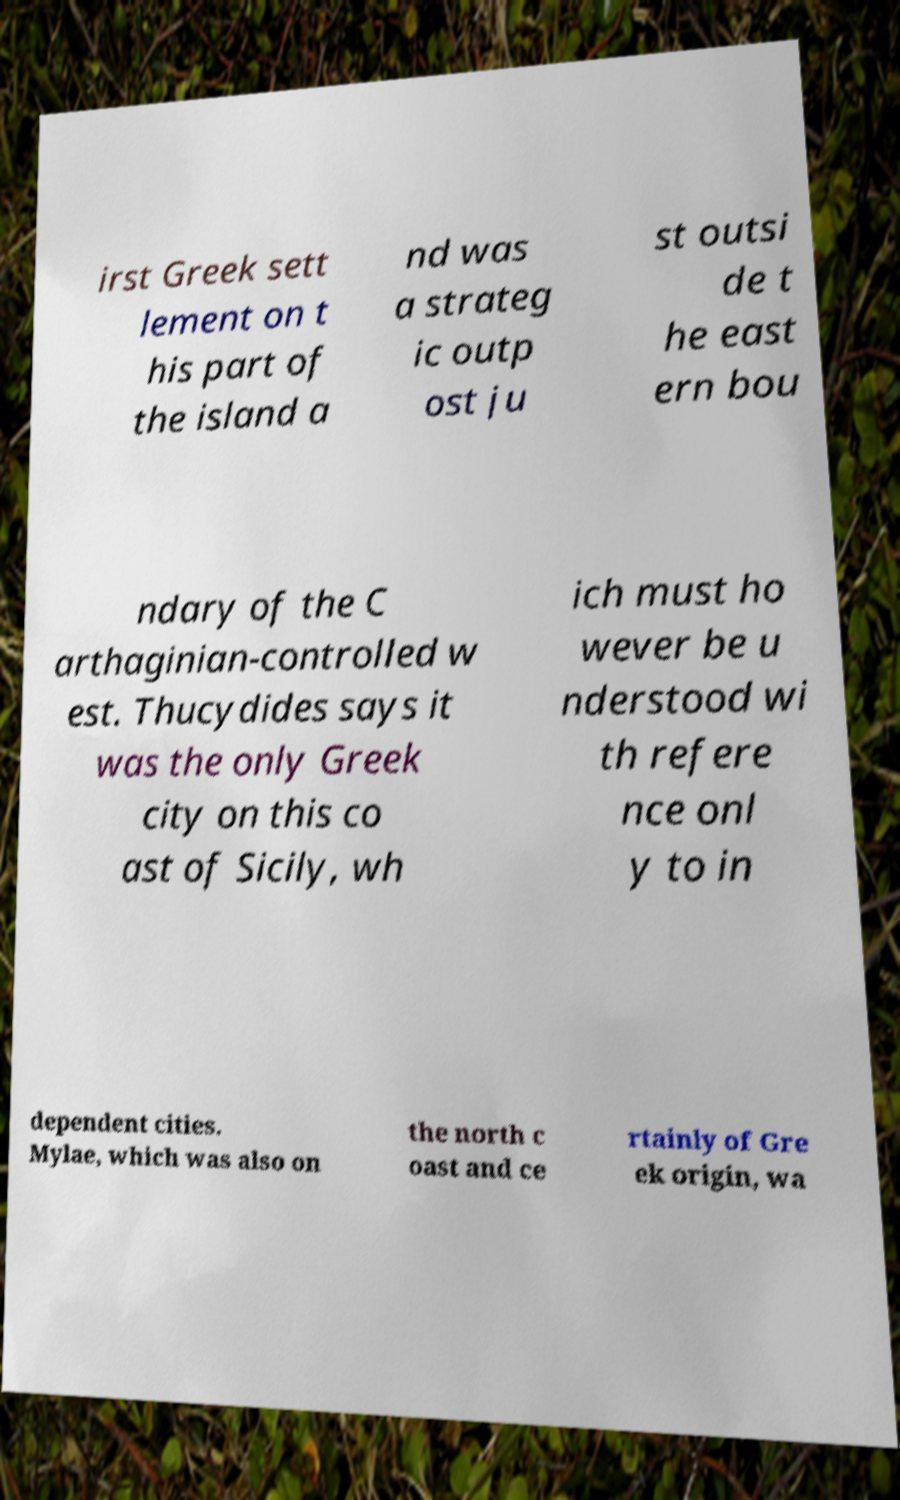I need the written content from this picture converted into text. Can you do that? irst Greek sett lement on t his part of the island a nd was a strateg ic outp ost ju st outsi de t he east ern bou ndary of the C arthaginian-controlled w est. Thucydides says it was the only Greek city on this co ast of Sicily, wh ich must ho wever be u nderstood wi th refere nce onl y to in dependent cities. Mylae, which was also on the north c oast and ce rtainly of Gre ek origin, wa 